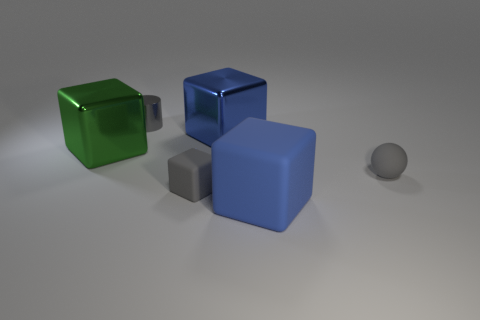Subtract all gray cubes. How many cubes are left? 3 Subtract 1 cubes. How many cubes are left? 3 Subtract all tiny gray blocks. How many blocks are left? 3 Subtract all yellow cubes. Subtract all green balls. How many cubes are left? 4 Add 3 small shiny cylinders. How many objects exist? 9 Subtract all balls. How many objects are left? 5 Add 1 blue objects. How many blue objects are left? 3 Add 6 tiny gray matte spheres. How many tiny gray matte spheres exist? 7 Subtract 0 red balls. How many objects are left? 6 Subtract all small brown metallic spheres. Subtract all shiny cylinders. How many objects are left? 5 